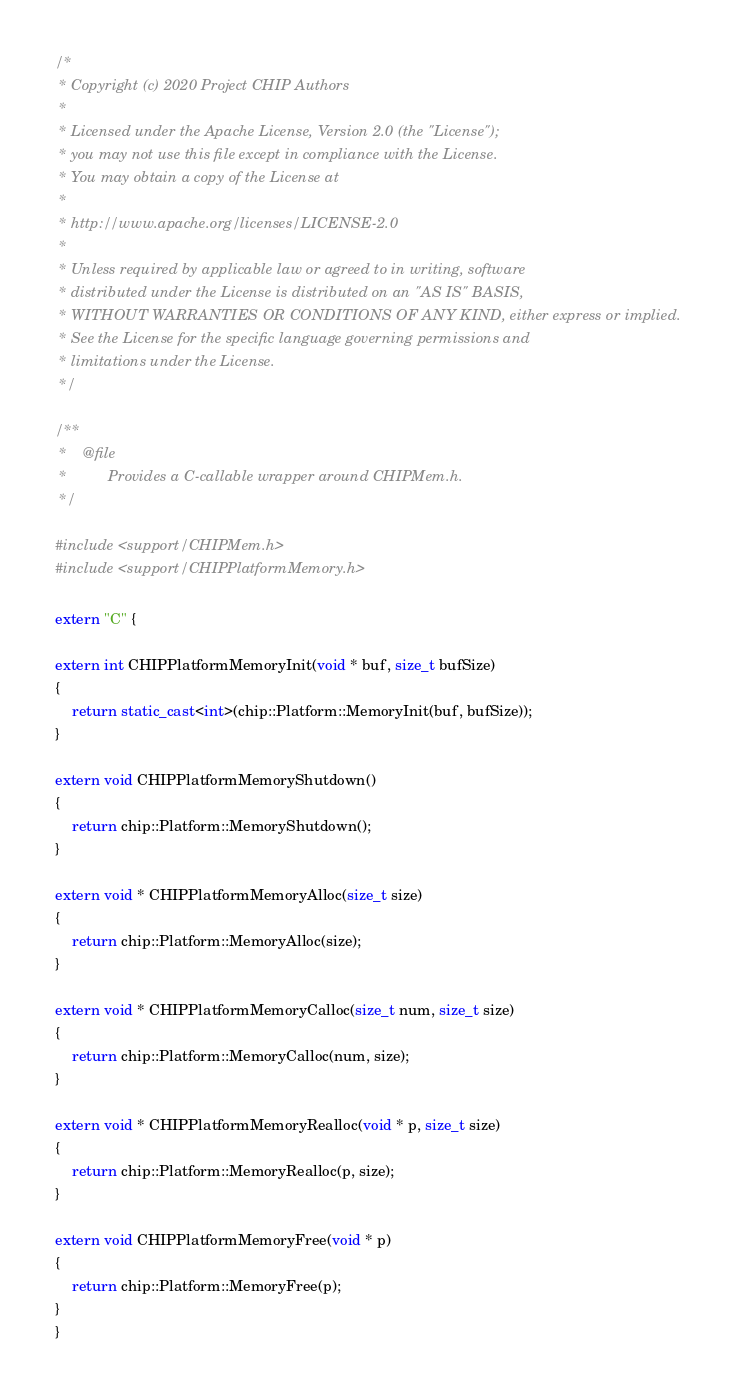<code> <loc_0><loc_0><loc_500><loc_500><_C++_>/*
 * Copyright (c) 2020 Project CHIP Authors
 *
 * Licensed under the Apache License, Version 2.0 (the "License");
 * you may not use this file except in compliance with the License.
 * You may obtain a copy of the License at
 *
 * http://www.apache.org/licenses/LICENSE-2.0
 *
 * Unless required by applicable law or agreed to in writing, software
 * distributed under the License is distributed on an "AS IS" BASIS,
 * WITHOUT WARRANTIES OR CONDITIONS OF ANY KIND, either express or implied.
 * See the License for the specific language governing permissions and
 * limitations under the License.
 */

/**
 *    @file
 *          Provides a C-callable wrapper around CHIPMem.h.
 */

#include <support/CHIPMem.h>
#include <support/CHIPPlatformMemory.h>

extern "C" {

extern int CHIPPlatformMemoryInit(void * buf, size_t bufSize)
{
    return static_cast<int>(chip::Platform::MemoryInit(buf, bufSize));
}

extern void CHIPPlatformMemoryShutdown()
{
    return chip::Platform::MemoryShutdown();
}

extern void * CHIPPlatformMemoryAlloc(size_t size)
{
    return chip::Platform::MemoryAlloc(size);
}

extern void * CHIPPlatformMemoryCalloc(size_t num, size_t size)
{
    return chip::Platform::MemoryCalloc(num, size);
}

extern void * CHIPPlatformMemoryRealloc(void * p, size_t size)
{
    return chip::Platform::MemoryRealloc(p, size);
}

extern void CHIPPlatformMemoryFree(void * p)
{
    return chip::Platform::MemoryFree(p);
}
}
</code> 